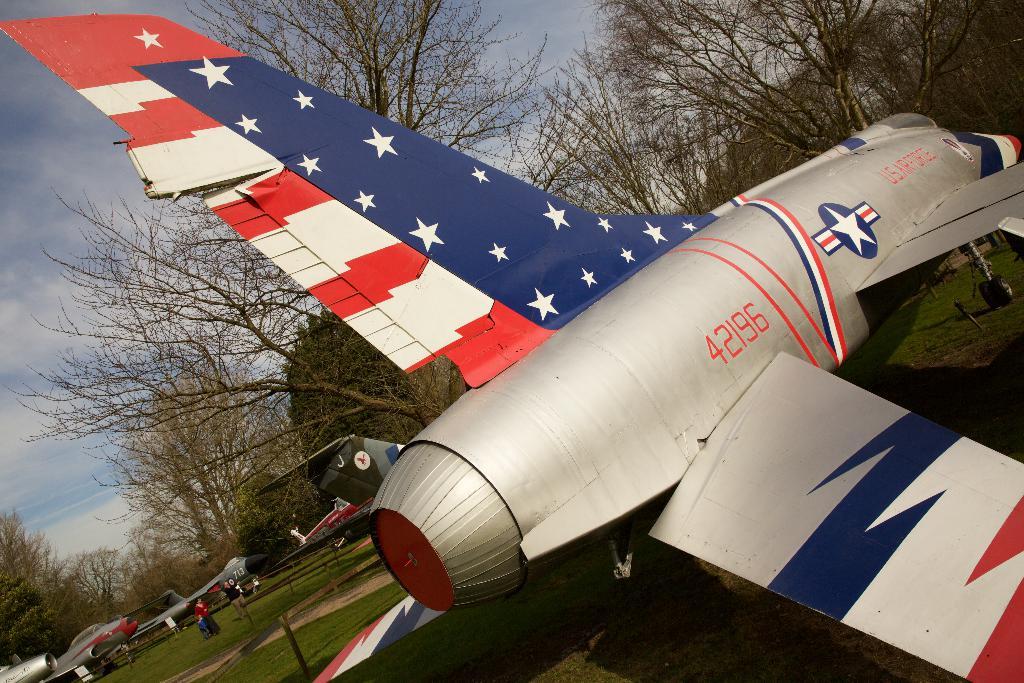What is the id number on the plane?
Your answer should be very brief. 42196. 